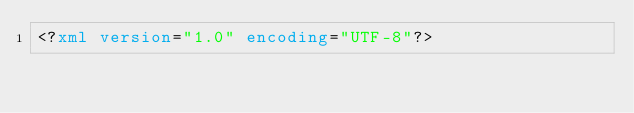<code> <loc_0><loc_0><loc_500><loc_500><_XML_><?xml version="1.0" encoding="UTF-8"?></code> 